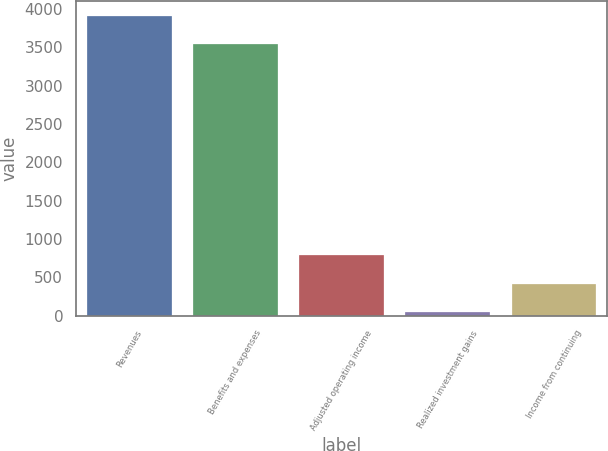<chart> <loc_0><loc_0><loc_500><loc_500><bar_chart><fcel>Revenues<fcel>Benefits and expenses<fcel>Adjusted operating income<fcel>Realized investment gains<fcel>Income from continuing<nl><fcel>3914.5<fcel>3548<fcel>785<fcel>52<fcel>418.5<nl></chart> 